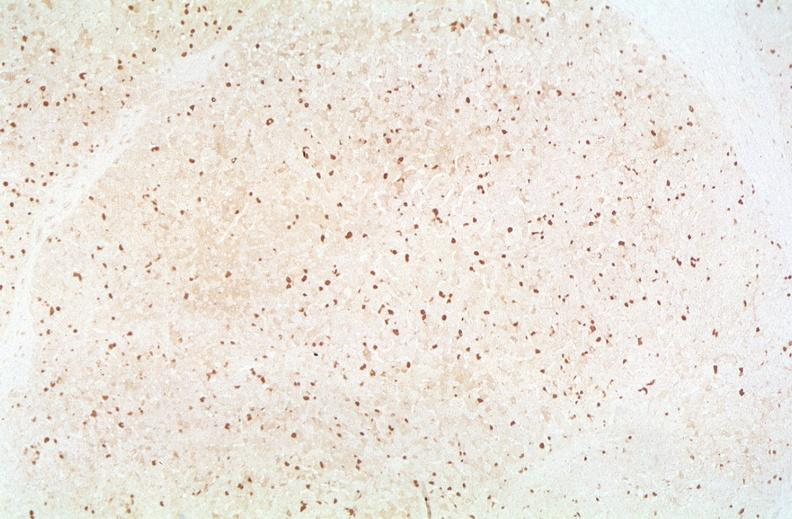s cachexia present?
Answer the question using a single word or phrase. No 